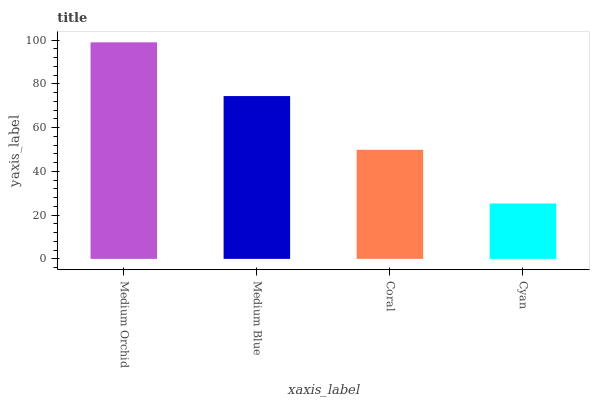Is Medium Blue the minimum?
Answer yes or no. No. Is Medium Blue the maximum?
Answer yes or no. No. Is Medium Orchid greater than Medium Blue?
Answer yes or no. Yes. Is Medium Blue less than Medium Orchid?
Answer yes or no. Yes. Is Medium Blue greater than Medium Orchid?
Answer yes or no. No. Is Medium Orchid less than Medium Blue?
Answer yes or no. No. Is Medium Blue the high median?
Answer yes or no. Yes. Is Coral the low median?
Answer yes or no. Yes. Is Medium Orchid the high median?
Answer yes or no. No. Is Medium Blue the low median?
Answer yes or no. No. 